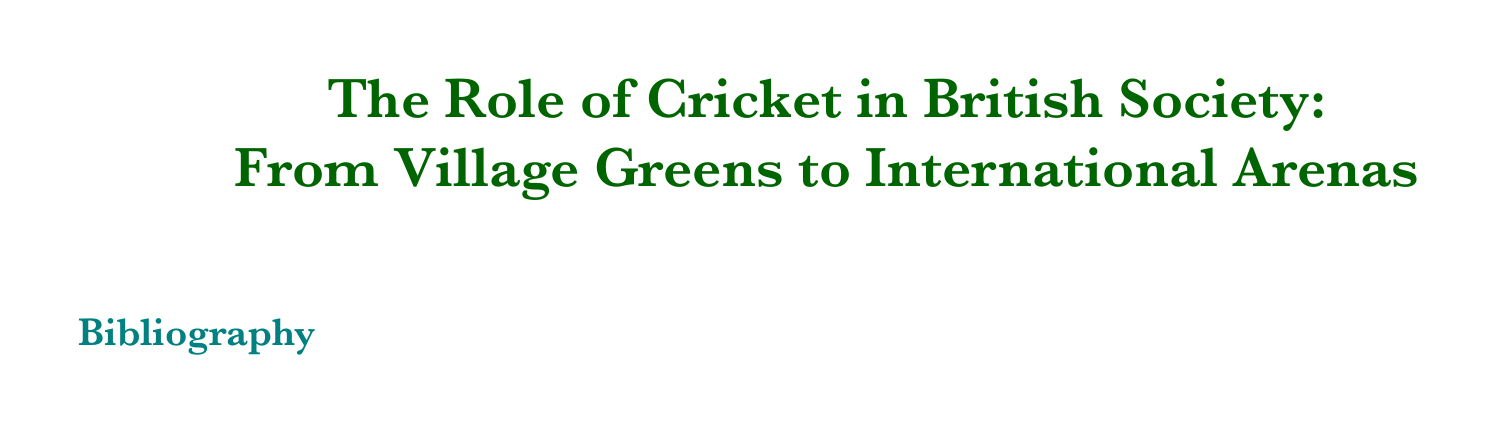What is the title of the book published in 2022? The title is given in the bibliography entry for the book published by Wisden in 2022.
Answer: The Cricketing Almanack Who authored the article titled "Village Cricket and Community Life in England"? The article's author is provided in the reference for the corresponding entry.
Answer: John Bale In what year was the article "Cricket and National Identity in Britain and the Commonwealth" published? The year can be found in the citation information for that article.
Answer: 2005 Which publisher released the book "Empire and Cricket: The South Asian Impact on an English Game"? The publisher is specified in the bibliographic entry for that book.
Answer: Bloomsbury Academic What is the volume number of the journal where the article "Ashes Series: A Cultural Touchstone" appeared? The volume number is included in the citation details of that article.
Answer: N/A Who is the author of the online resource titled "The History of Cricket in the UK"? The author's name is given in the citation for the online resource.
Answer: Marylebone Cricket Club What is the URL for the online resource about cricket's history? The URL is listed directly in the citation for that online resource.
Answer: https://www.lords.org/mcc/the-club/history-of-cricket What cultural event does the article by Atherton discuss? The event is mentioned in the title of the article by Atherton.
Answer: Ashes Series What volume of the journal "Sport in Society" includes the article about village cricket? The volume number can be found in the citation for that article.
Answer: 16 